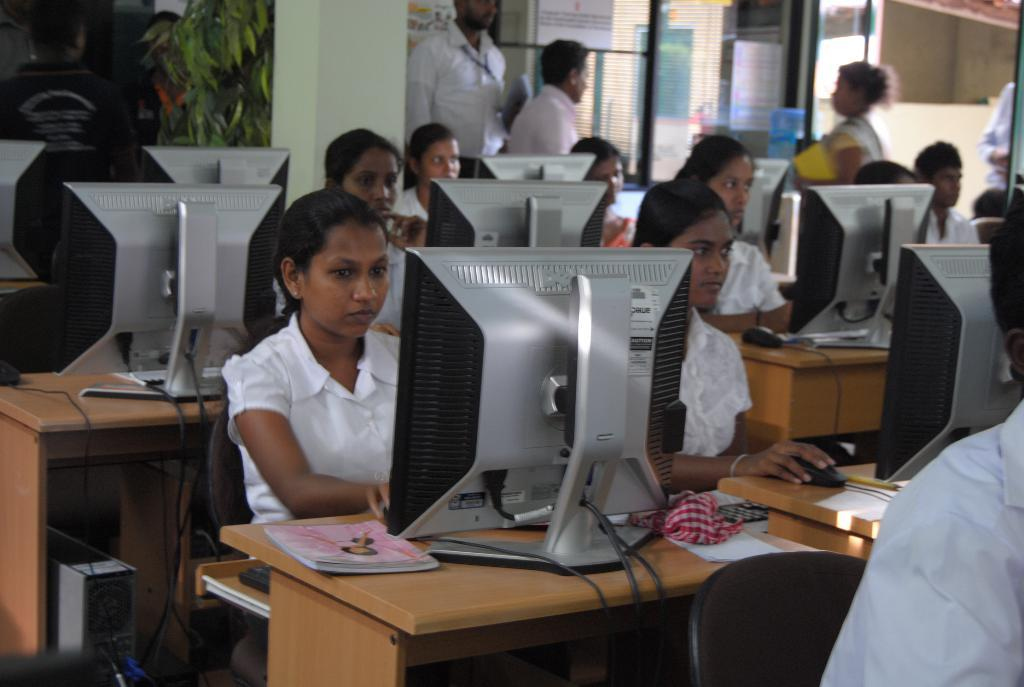Where is the image taken? The image is inside a classroom. What furniture is present in the classroom? There are multiple tables and chairs in the image. What are the people in the image doing? People are sitting on the chairs. What electronic devices are on the tables? There are desktop computers on the tables. What else can be seen on the tables besides computers? There are books on the tables. What architectural feature is visible in the background of the image? There is: There is a glass door in the background of the image. What type of net is being used to catch the ball in the image? There is no ball or net present in the image; it is a classroom setting with tables, chairs, computers, and books. 